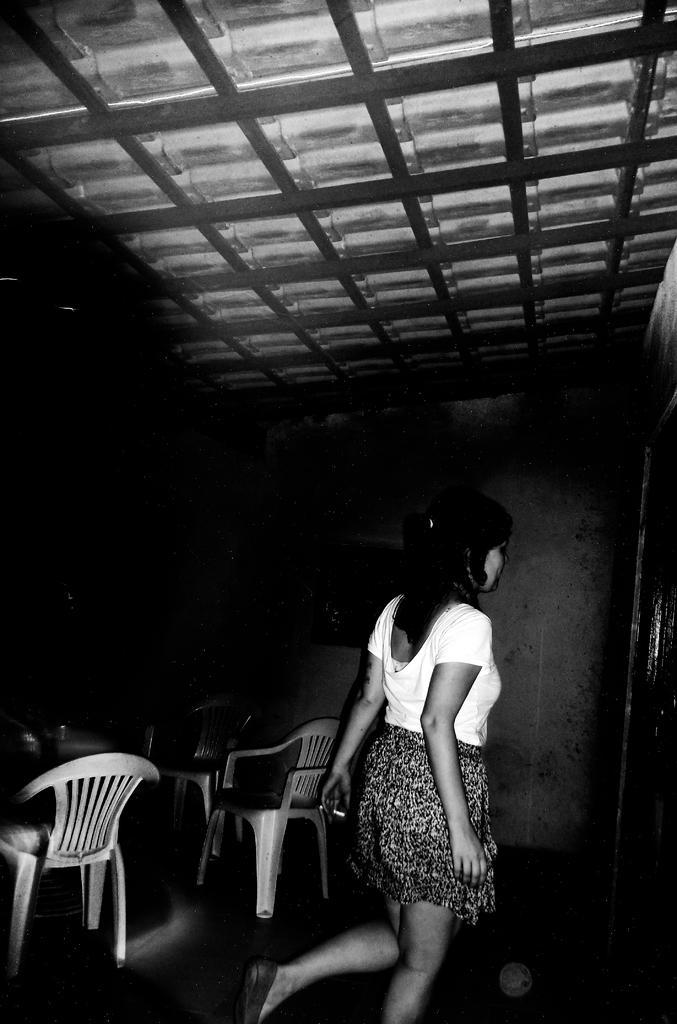What is the main subject of the image? There is a woman standing in the image. What can be seen in the background of the image? There are chairs in the background of the image. What is the setting of the image? There is a wall visible in the image, suggesting an indoor setting. How many minutes does the camera take to capture the woman in the image? There is no camera present in the image, so it is not possible to determine how long it takes to capture the woman. 